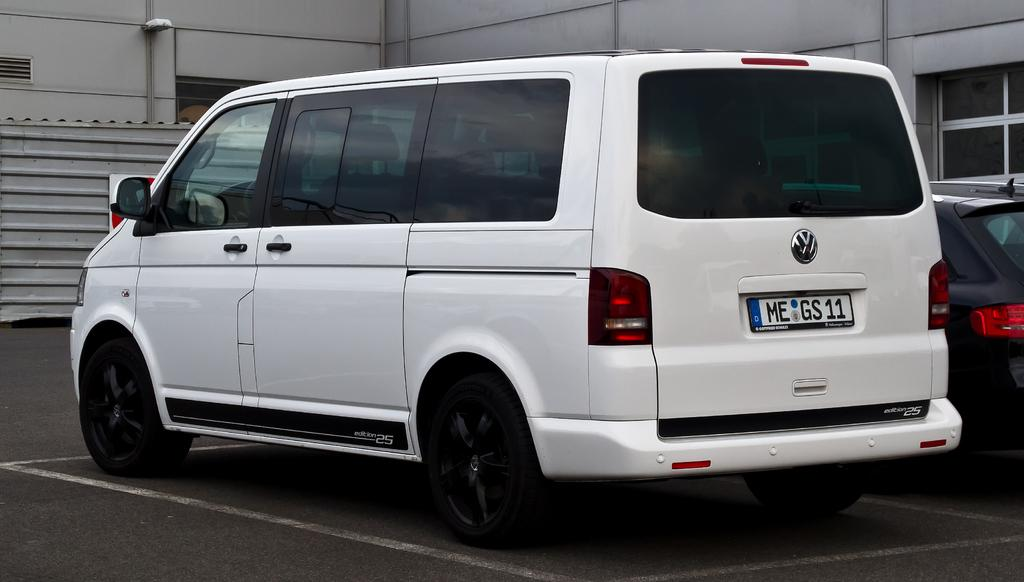<image>
Give a short and clear explanation of the subsequent image. A white Volkswagen van sitting in a parking lot by a grey building. 